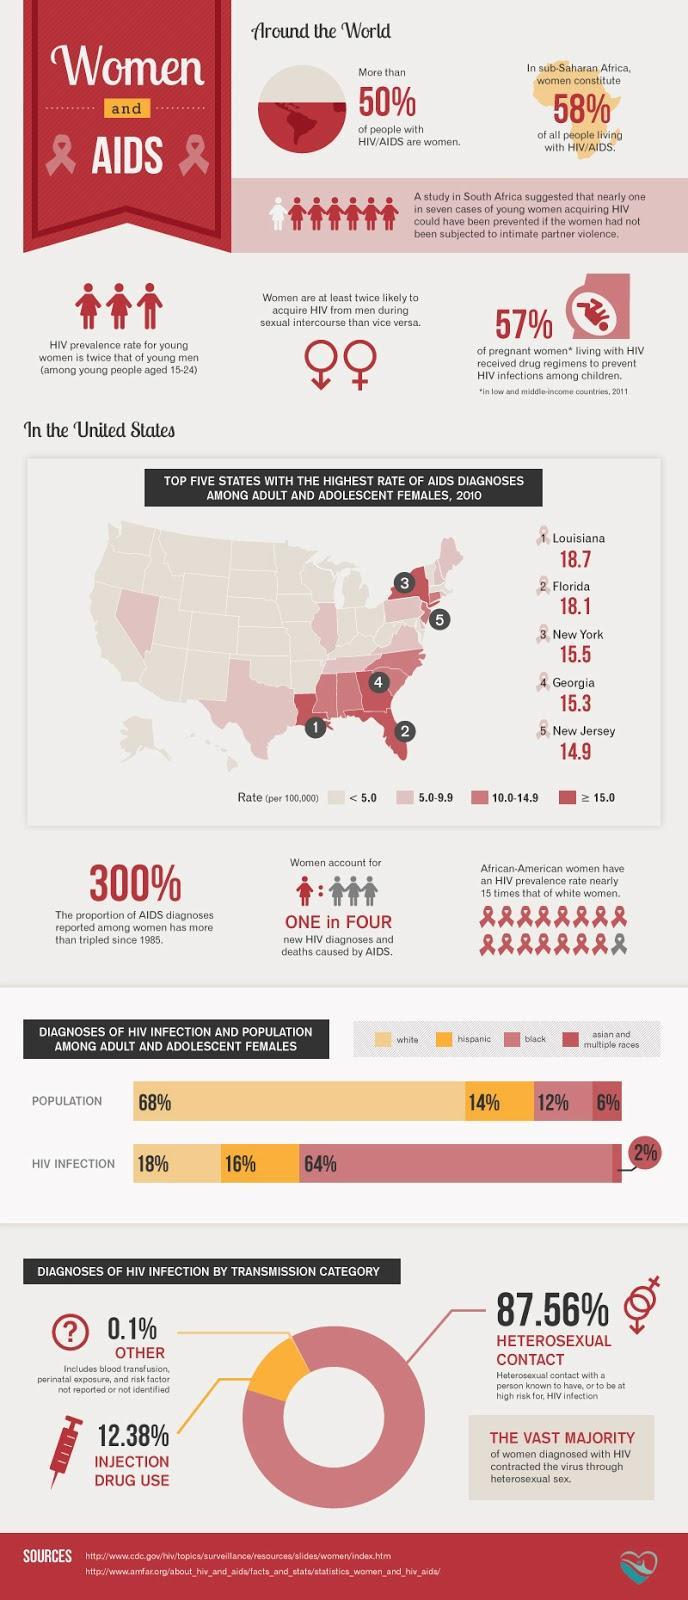What is the lowest percentage of HIV infection recorded?
Answer the question with a short phrase. 2% How many states have more than 15% rate of AIDS diagnoses ? 4 What percentage of HIV infection was not transmitted through heterosexual contact or injections? 0.1% What  percentage of women in the sub Saharan Africa have HIV, 50%, 58%, or 57%? 58% Which race has the second highest HIV infections but the largest percentage of population? white Which race has the highest percentage of HIV infections, white, hispanic, or black? black 